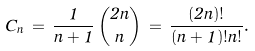Convert formula to latex. <formula><loc_0><loc_0><loc_500><loc_500>C _ { n } \, = \, \frac { 1 } { n + 1 } \, \binom { 2 n } { n } \, = \, \frac { ( 2 n ) ! } { ( n + 1 ) ! n ! } .</formula> 